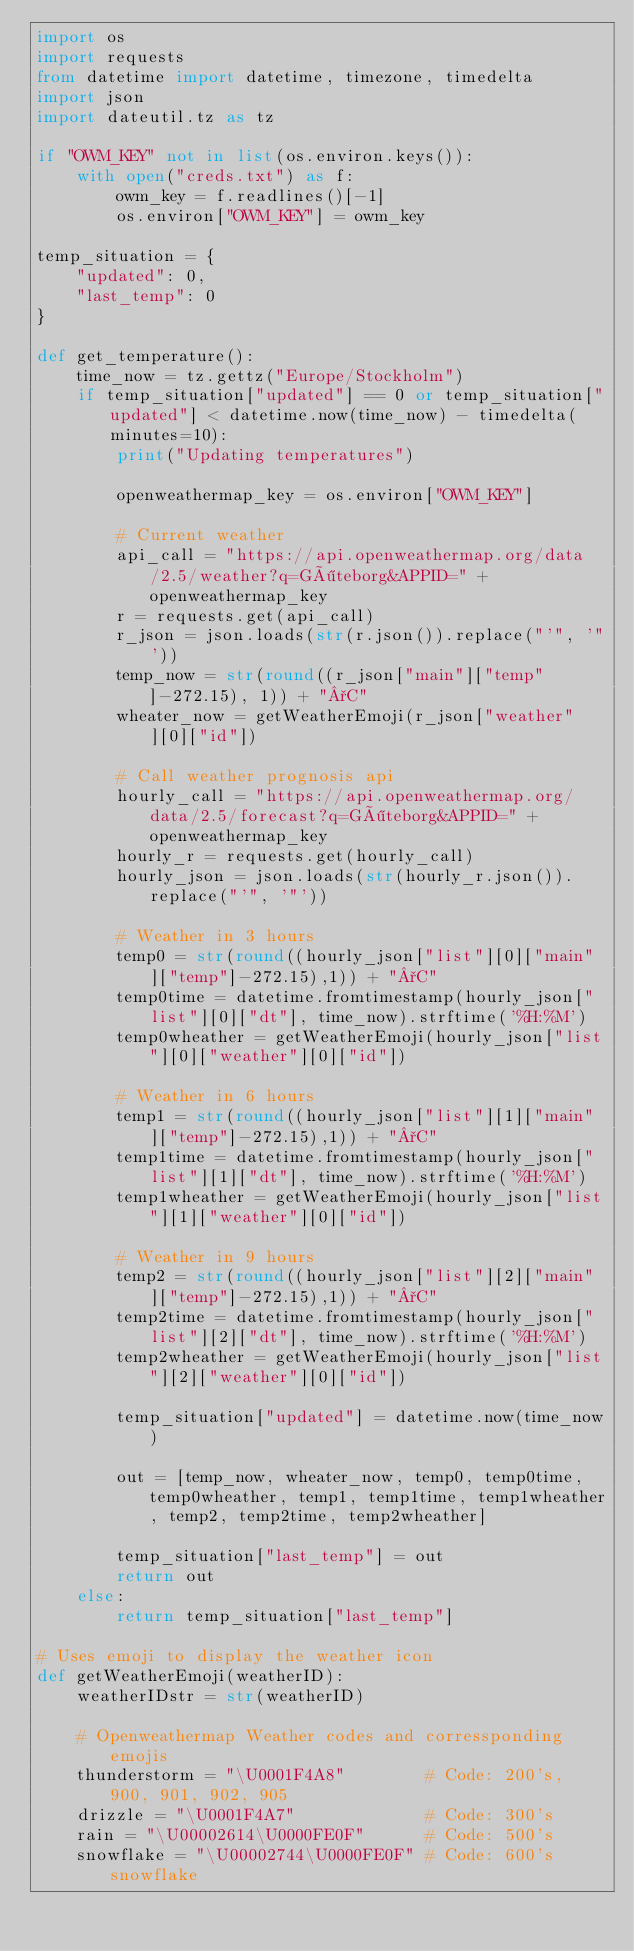<code> <loc_0><loc_0><loc_500><loc_500><_Python_>import os
import requests
from datetime import datetime, timezone, timedelta
import json
import dateutil.tz as tz

if "OWM_KEY" not in list(os.environ.keys()):
    with open("creds.txt") as f:
        owm_key = f.readlines()[-1]
        os.environ["OWM_KEY"] = owm_key

temp_situation = {
    "updated": 0,
    "last_temp": 0
}

def get_temperature():
    time_now = tz.gettz("Europe/Stockholm")
    if temp_situation["updated"] == 0 or temp_situation["updated"] < datetime.now(time_now) - timedelta(minutes=10):
        print("Updating temperatures")

        openweathermap_key = os.environ["OWM_KEY"]

        # Current weather
        api_call = "https://api.openweathermap.org/data/2.5/weather?q=Göteborg&APPID=" + openweathermap_key
        r = requests.get(api_call)
        r_json = json.loads(str(r.json()).replace("'", '"'))
        temp_now = str(round((r_json["main"]["temp"]-272.15), 1)) + "°C"
        wheater_now = getWeatherEmoji(r_json["weather"][0]["id"])
        
        # Call weather prognosis api
        hourly_call = "https://api.openweathermap.org/data/2.5/forecast?q=Göteborg&APPID=" + openweathermap_key
        hourly_r = requests.get(hourly_call)
        hourly_json = json.loads(str(hourly_r.json()).replace("'", '"'))

        # Weather in 3 hours
        temp0 = str(round((hourly_json["list"][0]["main"]["temp"]-272.15),1)) + "°C"
        temp0time = datetime.fromtimestamp(hourly_json["list"][0]["dt"], time_now).strftime('%H:%M')
        temp0wheather = getWeatherEmoji(hourly_json["list"][0]["weather"][0]["id"])

        # Weather in 6 hours
        temp1 = str(round((hourly_json["list"][1]["main"]["temp"]-272.15),1)) + "°C"
        temp1time = datetime.fromtimestamp(hourly_json["list"][1]["dt"], time_now).strftime('%H:%M')
        temp1wheather = getWeatherEmoji(hourly_json["list"][1]["weather"][0]["id"])

        # Weather in 9 hours
        temp2 = str(round((hourly_json["list"][2]["main"]["temp"]-272.15),1)) + "°C"
        temp2time = datetime.fromtimestamp(hourly_json["list"][2]["dt"], time_now).strftime('%H:%M')
        temp2wheather = getWeatherEmoji(hourly_json["list"][2]["weather"][0]["id"])
        
        temp_situation["updated"] = datetime.now(time_now)
        
        out = [temp_now, wheater_now, temp0, temp0time, temp0wheather, temp1, temp1time, temp1wheather, temp2, temp2time, temp2wheather]
        
        temp_situation["last_temp"] = out
        return out
    else:
        return temp_situation["last_temp"]

# Uses emoji to display the weather icon
def getWeatherEmoji(weatherID):
    weatherIDstr = str(weatherID)

    # Openweathermap Weather codes and corressponding emojis
    thunderstorm = "\U0001F4A8"        # Code: 200's, 900, 901, 902, 905
    drizzle = "\U0001F4A7"             # Code: 300's
    rain = "\U00002614\U0000FE0F"      # Code: 500's
    snowflake = "\U00002744\U0000FE0F" # Code: 600's snowflake</code> 